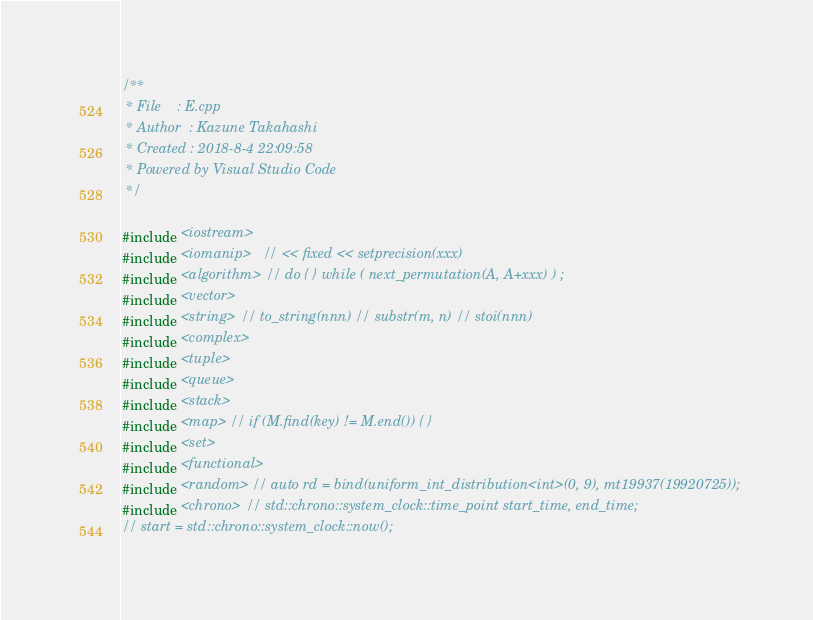<code> <loc_0><loc_0><loc_500><loc_500><_C++_>/**
 * File    : E.cpp
 * Author  : Kazune Takahashi
 * Created : 2018-8-4 22:09:58
 * Powered by Visual Studio Code
 */

#include <iostream>
#include <iomanip>   // << fixed << setprecision(xxx)
#include <algorithm> // do { } while ( next_permutation(A, A+xxx) ) ;
#include <vector>
#include <string> // to_string(nnn) // substr(m, n) // stoi(nnn)
#include <complex>
#include <tuple>
#include <queue>
#include <stack>
#include <map> // if (M.find(key) != M.end()) { }
#include <set>
#include <functional>
#include <random> // auto rd = bind(uniform_int_distribution<int>(0, 9), mt19937(19920725));
#include <chrono> // std::chrono::system_clock::time_point start_time, end_time;
// start = std::chrono::system_clock::now();</code> 